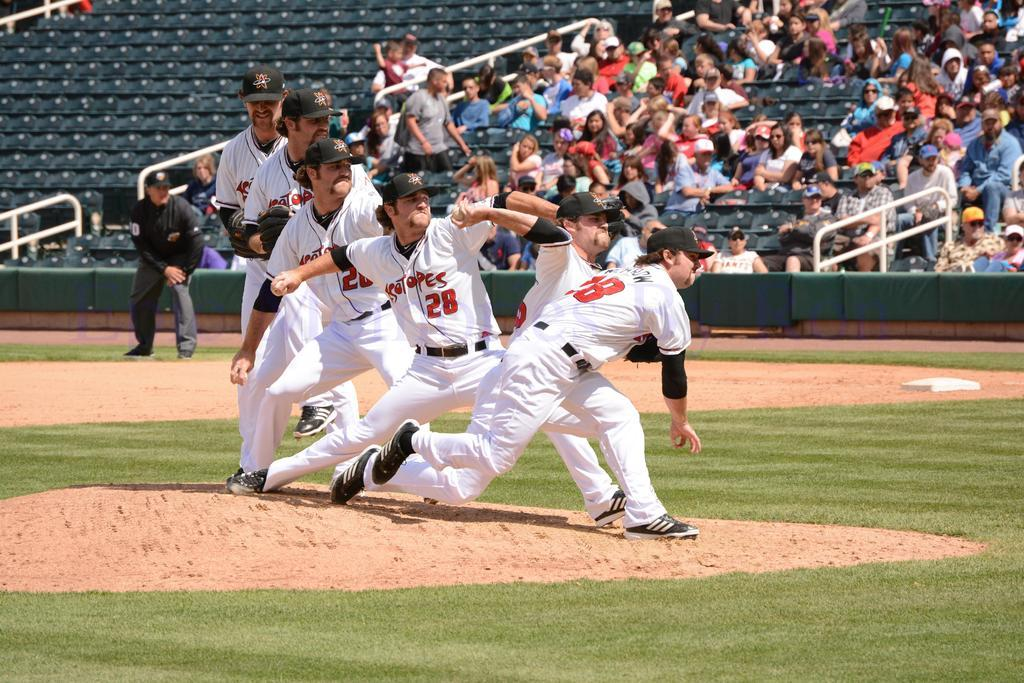<image>
Offer a succinct explanation of the picture presented. baseball players bunched up on the pitcher's mound wearing jerseys with number like 28 